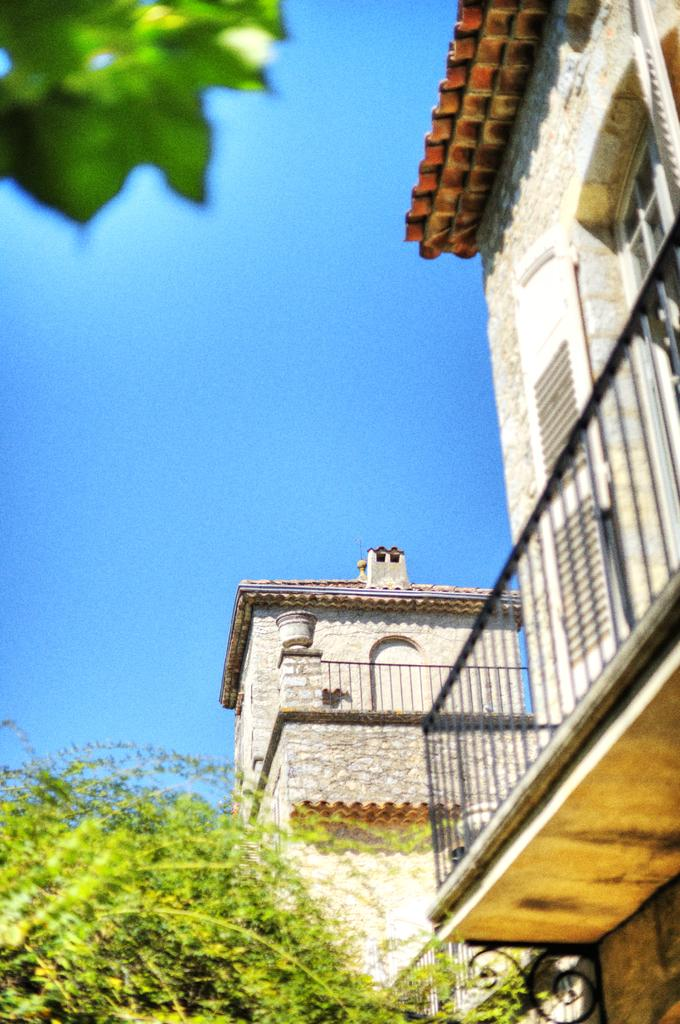What type of structures can be seen in the image? There are buildings in the image. What other natural elements are present in the image? There are trees in the image. What can be seen in the distance in the image? The sky is visible in the background of the image. What color is the magic curtain in the image? There is no magic curtain present in the image. How does the orange contribute to the image? There is no orange present in the image. 